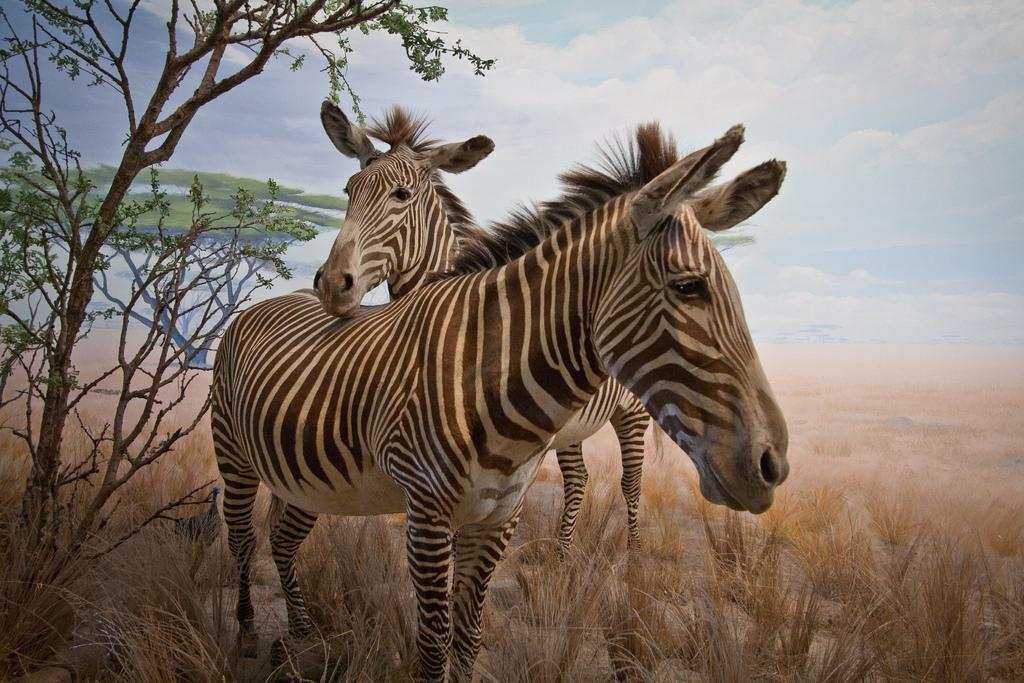What can be seen in the sky in the image? The sky is visible in the image, and there are clouds in the sky. What type of vegetation is present in the image? There are trees and grass in the image. Can you describe the appearance of one of the trees in the image? There is a tree that appears to be truncated towards the left of the image. What animals are present in the image? There are zebras in the image. Where is the table located in the image? There is no table present in the image. What type of plantation can be seen in the image? There is no plantation present in the image; it features a sky with clouds, trees, grass, and zebras. 